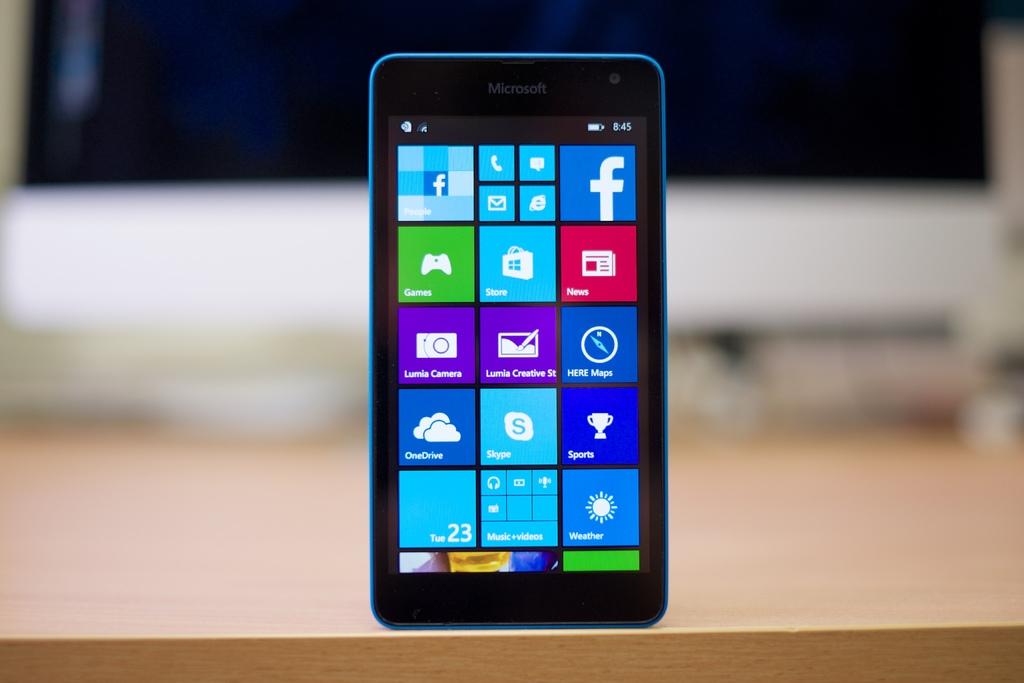What day was this photo taken?
Give a very brief answer. Tuesday. What brand is the phone?
Provide a succinct answer. Microsoft. 